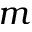Convert formula to latex. <formula><loc_0><loc_0><loc_500><loc_500>m</formula> 